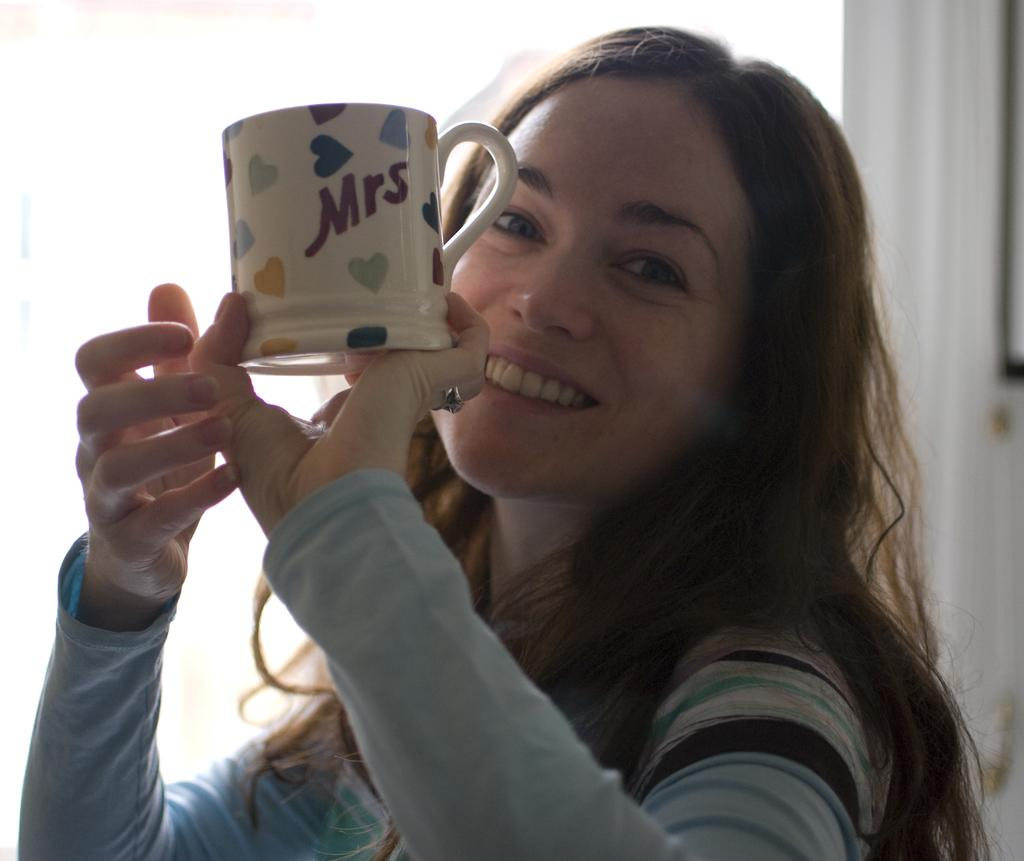What is the main subject of the image? The main subject of the image is a woman. What is the woman holding in the image? The woman is holding a cup. Can you tell me how many grapes are in the cup the woman is holding? There is no mention of grapes in the image, and the woman is holding a cup, not grapes. What type of wind can be felt in the image? There is no reference to wind in the image; it only features a woman holding a cup. 